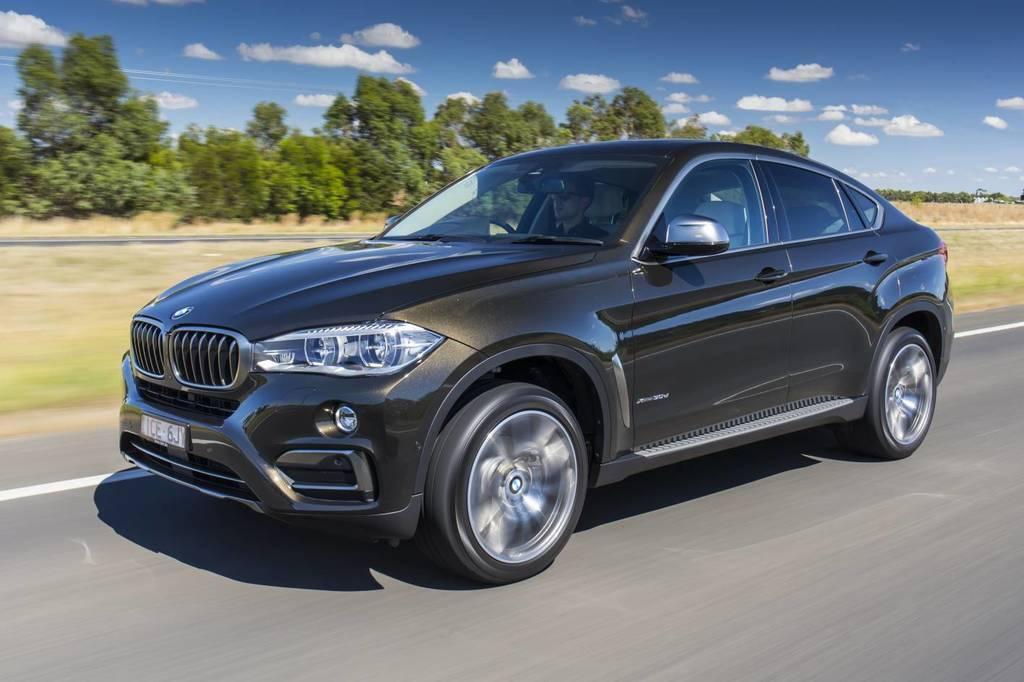Can you describe this image briefly? In the foreground of this image, there is a car moving on the road. In the background, there is grassland, trees and the sky. 